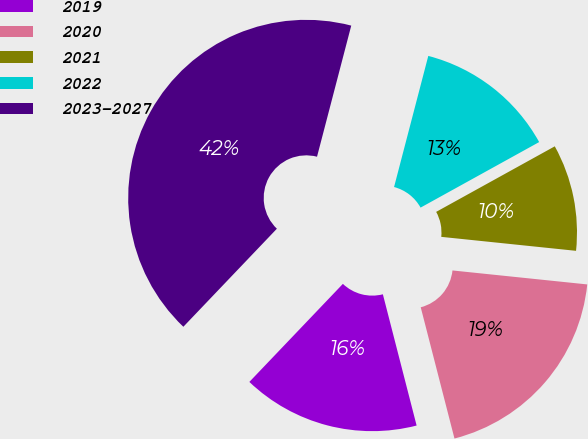Convert chart. <chart><loc_0><loc_0><loc_500><loc_500><pie_chart><fcel>2019<fcel>2020<fcel>2021<fcel>2022<fcel>2023-2027<nl><fcel>16.13%<fcel>19.35%<fcel>9.68%<fcel>12.9%<fcel>41.94%<nl></chart> 